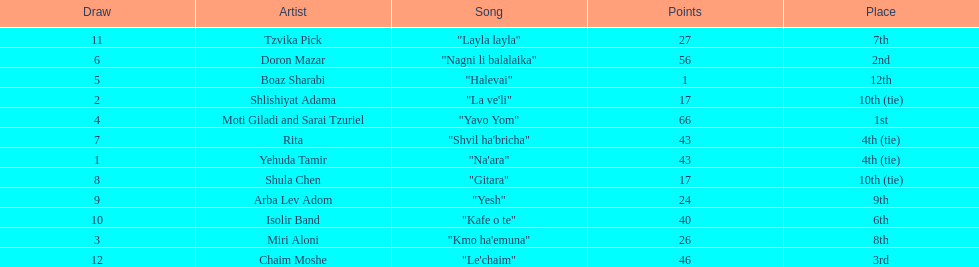What is the name of the song listed before the song "yesh"? "Gitara". 